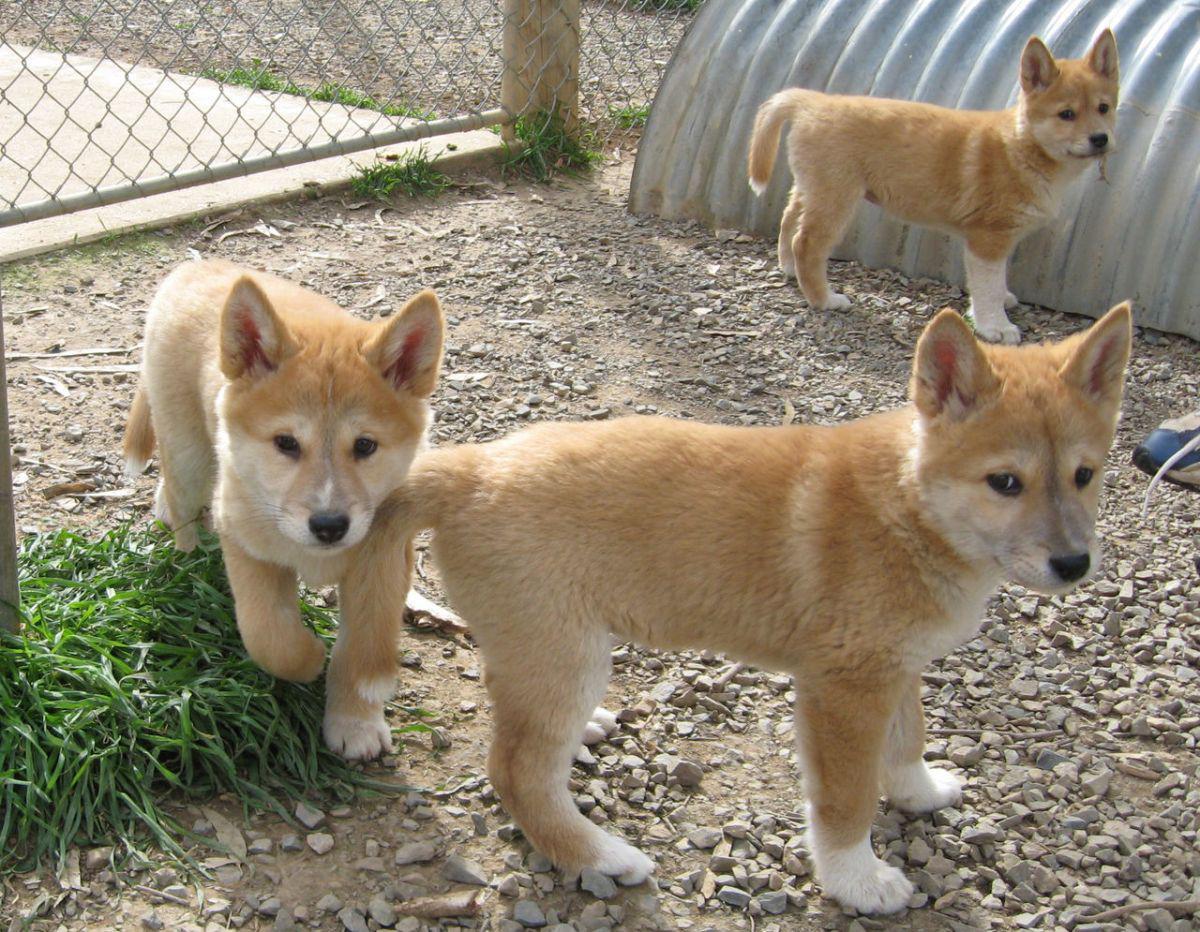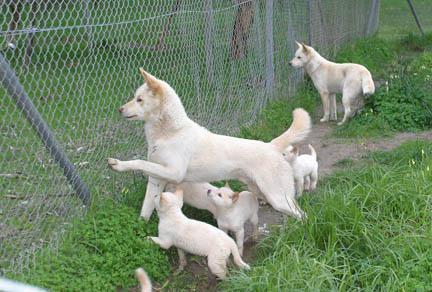The first image is the image on the left, the second image is the image on the right. Analyze the images presented: Is the assertion "The left image shows one reclining dog with extened front paws and upright head, and the right image shows one orange dingo gazing leftward." valid? Answer yes or no. No. 